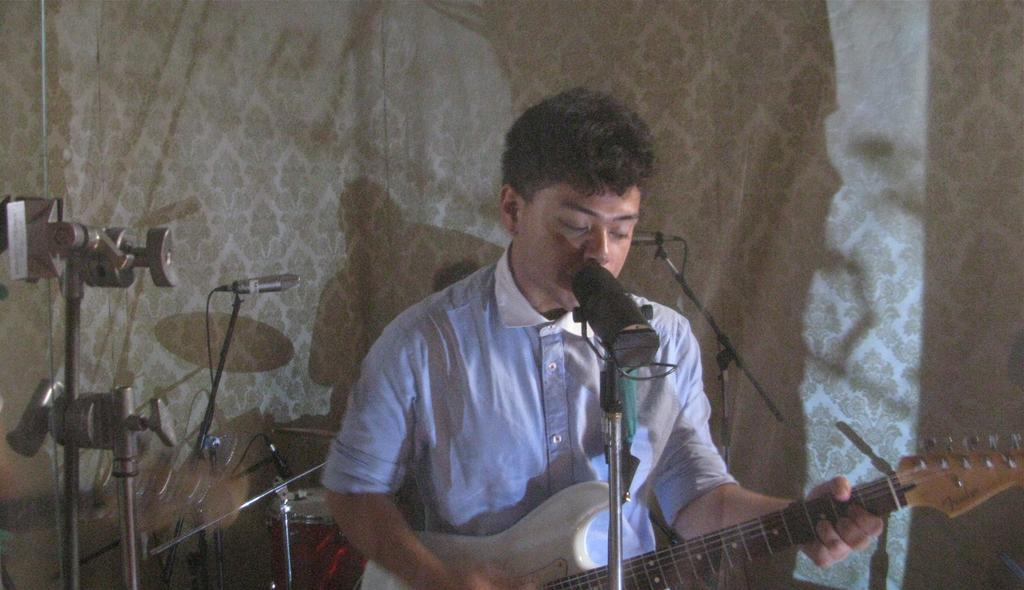What is the man in the image doing? The man is sitting, playing a guitar, and singing into a microphone. What instrument can be seen in the man's hands? The man is playing a guitar. Is there any other equipment visible in the image? Yes, there is a microphone in the background and drums in the background. What can be seen behind the man? There is a wall in the background. What is the size of the lake in the image? There is no lake present in the image. 